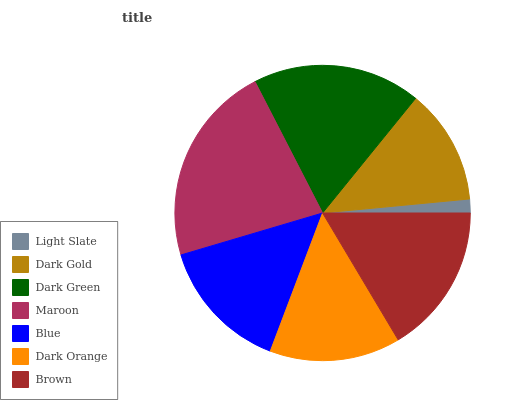Is Light Slate the minimum?
Answer yes or no. Yes. Is Maroon the maximum?
Answer yes or no. Yes. Is Dark Gold the minimum?
Answer yes or no. No. Is Dark Gold the maximum?
Answer yes or no. No. Is Dark Gold greater than Light Slate?
Answer yes or no. Yes. Is Light Slate less than Dark Gold?
Answer yes or no. Yes. Is Light Slate greater than Dark Gold?
Answer yes or no. No. Is Dark Gold less than Light Slate?
Answer yes or no. No. Is Blue the high median?
Answer yes or no. Yes. Is Blue the low median?
Answer yes or no. Yes. Is Maroon the high median?
Answer yes or no. No. Is Maroon the low median?
Answer yes or no. No. 